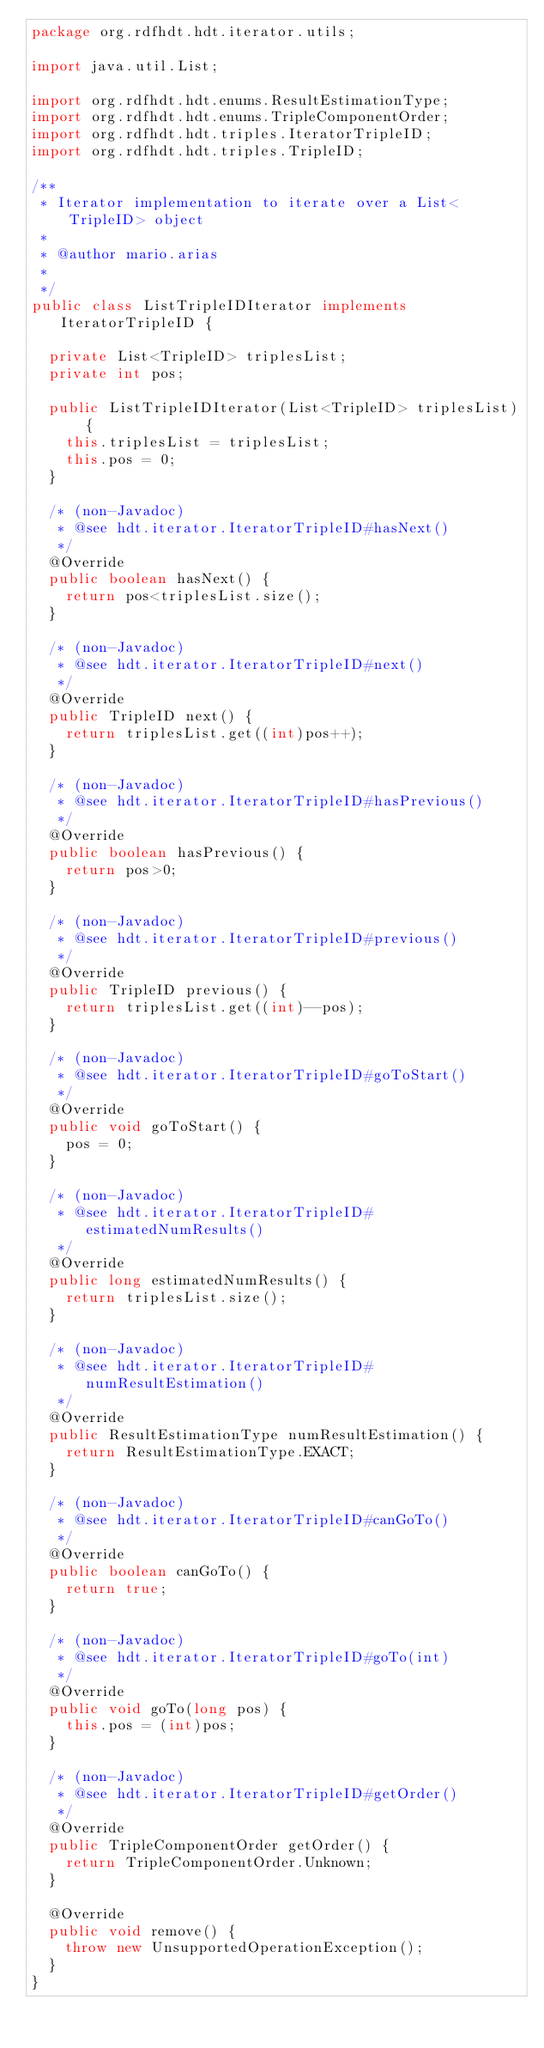Convert code to text. <code><loc_0><loc_0><loc_500><loc_500><_Java_>package org.rdfhdt.hdt.iterator.utils;

import java.util.List;

import org.rdfhdt.hdt.enums.ResultEstimationType;
import org.rdfhdt.hdt.enums.TripleComponentOrder;
import org.rdfhdt.hdt.triples.IteratorTripleID;
import org.rdfhdt.hdt.triples.TripleID;

/**
 * Iterator implementation to iterate over a List<TripleID> object
 * 
 * @author mario.arias
 *
 */
public class ListTripleIDIterator implements IteratorTripleID {

	private List<TripleID> triplesList;
	private int pos;

	public ListTripleIDIterator(List<TripleID> triplesList) {
		this.triplesList = triplesList;
		this.pos = 0;
	}

	/* (non-Javadoc)
	 * @see hdt.iterator.IteratorTripleID#hasNext()
	 */
	@Override
	public boolean hasNext() {
		return pos<triplesList.size();
	}

	/* (non-Javadoc)
	 * @see hdt.iterator.IteratorTripleID#next()
	 */
	@Override
	public TripleID next() {
		return triplesList.get((int)pos++);
	}

	/* (non-Javadoc)
	 * @see hdt.iterator.IteratorTripleID#hasPrevious()
	 */
	@Override
	public boolean hasPrevious() {
		return pos>0;
	}

	/* (non-Javadoc)
	 * @see hdt.iterator.IteratorTripleID#previous()
	 */
	@Override
	public TripleID previous() {
		return triplesList.get((int)--pos);
	}

	/* (non-Javadoc)
	 * @see hdt.iterator.IteratorTripleID#goToStart()
	 */
	@Override
	public void goToStart() {
		pos = 0;
	}

	/* (non-Javadoc)
	 * @see hdt.iterator.IteratorTripleID#estimatedNumResults()
	 */
	@Override
	public long estimatedNumResults() {
		return triplesList.size();
	}

	/* (non-Javadoc)
	 * @see hdt.iterator.IteratorTripleID#numResultEstimation()
	 */
	@Override
	public ResultEstimationType numResultEstimation() {
		return ResultEstimationType.EXACT;
	}

	/* (non-Javadoc)
	 * @see hdt.iterator.IteratorTripleID#canGoTo()
	 */
	@Override
	public boolean canGoTo() {
		return true;
	}

	/* (non-Javadoc)
	 * @see hdt.iterator.IteratorTripleID#goTo(int)
	 */
	@Override
	public void goTo(long pos) {
		this.pos = (int)pos;
	}

	/* (non-Javadoc)
	 * @see hdt.iterator.IteratorTripleID#getOrder()
	 */
	@Override
	public TripleComponentOrder getOrder() {
		return TripleComponentOrder.Unknown;
	}

	@Override
	public void remove() {
		throw new UnsupportedOperationException();
	}
}</code> 